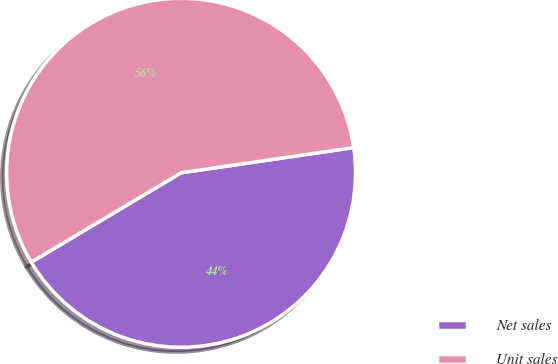Convert chart to OTSL. <chart><loc_0><loc_0><loc_500><loc_500><pie_chart><fcel>Net sales<fcel>Unit sales<nl><fcel>43.75%<fcel>56.25%<nl></chart> 